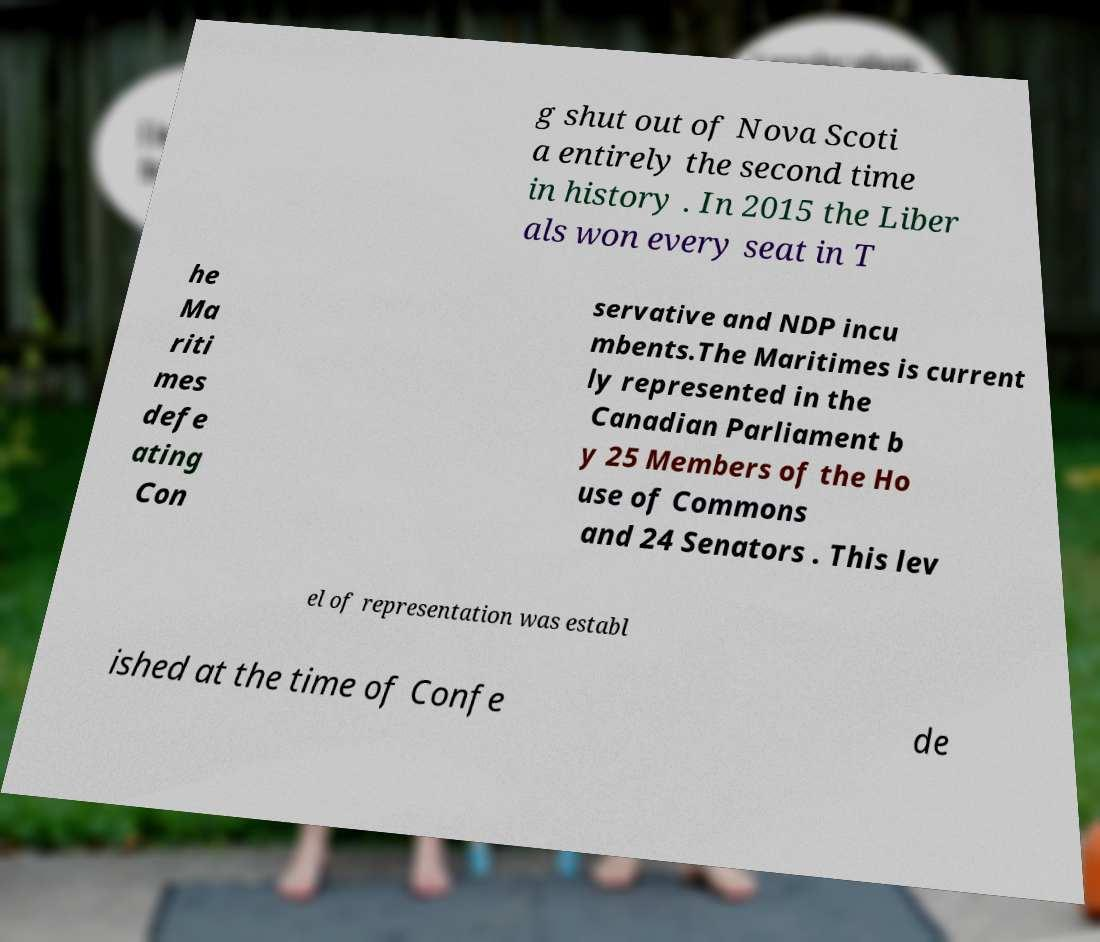Can you accurately transcribe the text from the provided image for me? g shut out of Nova Scoti a entirely the second time in history . In 2015 the Liber als won every seat in T he Ma riti mes defe ating Con servative and NDP incu mbents.The Maritimes is current ly represented in the Canadian Parliament b y 25 Members of the Ho use of Commons and 24 Senators . This lev el of representation was establ ished at the time of Confe de 